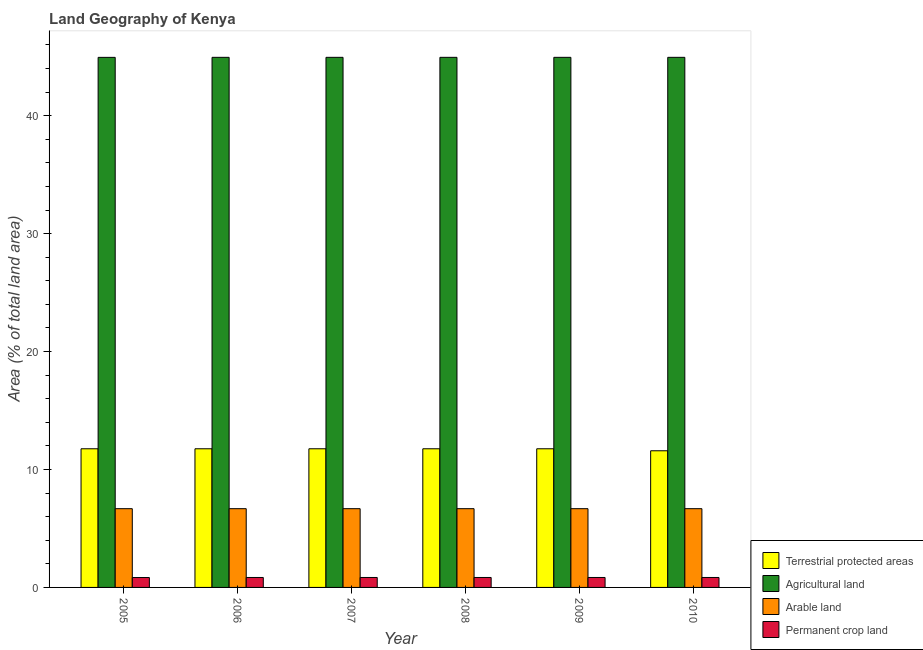How many different coloured bars are there?
Your answer should be compact. 4. How many groups of bars are there?
Offer a very short reply. 6. What is the label of the 1st group of bars from the left?
Your answer should be compact. 2005. What is the percentage of area under permanent crop land in 2008?
Make the answer very short. 0.84. Across all years, what is the maximum percentage of area under permanent crop land?
Your answer should be very brief. 0.84. Across all years, what is the minimum percentage of area under arable land?
Keep it short and to the point. 6.68. In which year was the percentage of area under agricultural land maximum?
Offer a very short reply. 2006. What is the total percentage of area under arable land in the graph?
Keep it short and to the point. 40.06. What is the difference between the percentage of area under agricultural land in 2008 and the percentage of area under permanent crop land in 2006?
Your answer should be compact. 0. What is the average percentage of area under permanent crop land per year?
Provide a succinct answer. 0.84. In how many years, is the percentage of area under permanent crop land greater than 36 %?
Ensure brevity in your answer.  0. What is the ratio of the percentage of area under arable land in 2006 to that in 2009?
Keep it short and to the point. 1. Is the difference between the percentage of area under permanent crop land in 2008 and 2010 greater than the difference between the percentage of land under terrestrial protection in 2008 and 2010?
Provide a succinct answer. No. What is the difference between the highest and the lowest percentage of land under terrestrial protection?
Your response must be concise. 0.17. In how many years, is the percentage of area under permanent crop land greater than the average percentage of area under permanent crop land taken over all years?
Your response must be concise. 5. Is the sum of the percentage of area under arable land in 2005 and 2008 greater than the maximum percentage of land under terrestrial protection across all years?
Give a very brief answer. Yes. Is it the case that in every year, the sum of the percentage of area under permanent crop land and percentage of area under arable land is greater than the sum of percentage of area under agricultural land and percentage of land under terrestrial protection?
Provide a short and direct response. No. What does the 4th bar from the left in 2010 represents?
Keep it short and to the point. Permanent crop land. What does the 4th bar from the right in 2008 represents?
Offer a terse response. Terrestrial protected areas. Are all the bars in the graph horizontal?
Offer a very short reply. No. How many years are there in the graph?
Ensure brevity in your answer.  6. Does the graph contain grids?
Make the answer very short. No. How many legend labels are there?
Your response must be concise. 4. How are the legend labels stacked?
Provide a succinct answer. Vertical. What is the title of the graph?
Provide a short and direct response. Land Geography of Kenya. What is the label or title of the X-axis?
Your answer should be compact. Year. What is the label or title of the Y-axis?
Ensure brevity in your answer.  Area (% of total land area). What is the Area (% of total land area) of Terrestrial protected areas in 2005?
Provide a short and direct response. 11.76. What is the Area (% of total land area) of Agricultural land in 2005?
Offer a terse response. 44.94. What is the Area (% of total land area) in Arable land in 2005?
Offer a very short reply. 6.68. What is the Area (% of total land area) of Permanent crop land in 2005?
Keep it short and to the point. 0.84. What is the Area (% of total land area) in Terrestrial protected areas in 2006?
Ensure brevity in your answer.  11.76. What is the Area (% of total land area) in Agricultural land in 2006?
Your answer should be very brief. 44.95. What is the Area (% of total land area) of Arable land in 2006?
Provide a succinct answer. 6.68. What is the Area (% of total land area) of Permanent crop land in 2006?
Make the answer very short. 0.84. What is the Area (% of total land area) in Terrestrial protected areas in 2007?
Your answer should be very brief. 11.76. What is the Area (% of total land area) in Agricultural land in 2007?
Offer a very short reply. 44.95. What is the Area (% of total land area) of Arable land in 2007?
Your answer should be very brief. 6.68. What is the Area (% of total land area) in Permanent crop land in 2007?
Offer a very short reply. 0.84. What is the Area (% of total land area) of Terrestrial protected areas in 2008?
Provide a succinct answer. 11.76. What is the Area (% of total land area) in Agricultural land in 2008?
Offer a very short reply. 44.95. What is the Area (% of total land area) of Arable land in 2008?
Make the answer very short. 6.68. What is the Area (% of total land area) in Permanent crop land in 2008?
Provide a short and direct response. 0.84. What is the Area (% of total land area) in Terrestrial protected areas in 2009?
Your answer should be very brief. 11.76. What is the Area (% of total land area) in Agricultural land in 2009?
Your answer should be very brief. 44.95. What is the Area (% of total land area) in Arable land in 2009?
Provide a succinct answer. 6.68. What is the Area (% of total land area) in Permanent crop land in 2009?
Offer a very short reply. 0.84. What is the Area (% of total land area) of Terrestrial protected areas in 2010?
Ensure brevity in your answer.  11.59. What is the Area (% of total land area) in Agricultural land in 2010?
Provide a succinct answer. 44.95. What is the Area (% of total land area) of Arable land in 2010?
Your response must be concise. 6.68. What is the Area (% of total land area) in Permanent crop land in 2010?
Keep it short and to the point. 0.84. Across all years, what is the maximum Area (% of total land area) of Terrestrial protected areas?
Keep it short and to the point. 11.76. Across all years, what is the maximum Area (% of total land area) in Agricultural land?
Give a very brief answer. 44.95. Across all years, what is the maximum Area (% of total land area) of Arable land?
Offer a very short reply. 6.68. Across all years, what is the maximum Area (% of total land area) of Permanent crop land?
Offer a terse response. 0.84. Across all years, what is the minimum Area (% of total land area) in Terrestrial protected areas?
Make the answer very short. 11.59. Across all years, what is the minimum Area (% of total land area) in Agricultural land?
Offer a terse response. 44.94. Across all years, what is the minimum Area (% of total land area) in Arable land?
Your answer should be very brief. 6.68. Across all years, what is the minimum Area (% of total land area) in Permanent crop land?
Ensure brevity in your answer.  0.84. What is the total Area (% of total land area) of Terrestrial protected areas in the graph?
Keep it short and to the point. 70.37. What is the total Area (% of total land area) of Agricultural land in the graph?
Keep it short and to the point. 269.67. What is the total Area (% of total land area) in Arable land in the graph?
Your answer should be compact. 40.06. What is the total Area (% of total land area) of Permanent crop land in the graph?
Keep it short and to the point. 5.06. What is the difference between the Area (% of total land area) of Terrestrial protected areas in 2005 and that in 2006?
Keep it short and to the point. 0. What is the difference between the Area (% of total land area) of Agricultural land in 2005 and that in 2006?
Your answer should be compact. -0. What is the difference between the Area (% of total land area) of Arable land in 2005 and that in 2006?
Ensure brevity in your answer.  0. What is the difference between the Area (% of total land area) in Permanent crop land in 2005 and that in 2006?
Keep it short and to the point. -0. What is the difference between the Area (% of total land area) of Agricultural land in 2005 and that in 2007?
Ensure brevity in your answer.  -0. What is the difference between the Area (% of total land area) of Permanent crop land in 2005 and that in 2007?
Provide a succinct answer. -0. What is the difference between the Area (% of total land area) in Terrestrial protected areas in 2005 and that in 2008?
Ensure brevity in your answer.  0. What is the difference between the Area (% of total land area) in Agricultural land in 2005 and that in 2008?
Your response must be concise. -0. What is the difference between the Area (% of total land area) of Permanent crop land in 2005 and that in 2008?
Your answer should be very brief. -0. What is the difference between the Area (% of total land area) in Agricultural land in 2005 and that in 2009?
Your answer should be very brief. -0. What is the difference between the Area (% of total land area) in Permanent crop land in 2005 and that in 2009?
Your answer should be very brief. -0. What is the difference between the Area (% of total land area) in Terrestrial protected areas in 2005 and that in 2010?
Make the answer very short. 0.17. What is the difference between the Area (% of total land area) in Agricultural land in 2005 and that in 2010?
Offer a very short reply. -0. What is the difference between the Area (% of total land area) in Permanent crop land in 2005 and that in 2010?
Keep it short and to the point. -0. What is the difference between the Area (% of total land area) in Terrestrial protected areas in 2006 and that in 2007?
Provide a succinct answer. 0. What is the difference between the Area (% of total land area) of Terrestrial protected areas in 2006 and that in 2008?
Provide a short and direct response. 0. What is the difference between the Area (% of total land area) of Arable land in 2006 and that in 2008?
Make the answer very short. 0. What is the difference between the Area (% of total land area) of Permanent crop land in 2006 and that in 2008?
Provide a short and direct response. 0. What is the difference between the Area (% of total land area) of Terrestrial protected areas in 2006 and that in 2009?
Make the answer very short. 0. What is the difference between the Area (% of total land area) of Agricultural land in 2006 and that in 2009?
Keep it short and to the point. 0. What is the difference between the Area (% of total land area) in Arable land in 2006 and that in 2009?
Offer a terse response. 0. What is the difference between the Area (% of total land area) in Terrestrial protected areas in 2006 and that in 2010?
Ensure brevity in your answer.  0.17. What is the difference between the Area (% of total land area) of Terrestrial protected areas in 2007 and that in 2008?
Your answer should be very brief. 0. What is the difference between the Area (% of total land area) in Arable land in 2007 and that in 2008?
Provide a succinct answer. 0. What is the difference between the Area (% of total land area) in Arable land in 2007 and that in 2009?
Provide a succinct answer. 0. What is the difference between the Area (% of total land area) in Terrestrial protected areas in 2007 and that in 2010?
Offer a very short reply. 0.17. What is the difference between the Area (% of total land area) of Permanent crop land in 2007 and that in 2010?
Ensure brevity in your answer.  0. What is the difference between the Area (% of total land area) of Arable land in 2008 and that in 2009?
Offer a terse response. 0. What is the difference between the Area (% of total land area) of Terrestrial protected areas in 2008 and that in 2010?
Offer a terse response. 0.17. What is the difference between the Area (% of total land area) of Agricultural land in 2008 and that in 2010?
Your answer should be very brief. 0. What is the difference between the Area (% of total land area) of Arable land in 2008 and that in 2010?
Offer a very short reply. 0. What is the difference between the Area (% of total land area) in Permanent crop land in 2008 and that in 2010?
Your response must be concise. 0. What is the difference between the Area (% of total land area) of Terrestrial protected areas in 2009 and that in 2010?
Your answer should be very brief. 0.17. What is the difference between the Area (% of total land area) of Agricultural land in 2009 and that in 2010?
Your answer should be very brief. 0. What is the difference between the Area (% of total land area) of Permanent crop land in 2009 and that in 2010?
Keep it short and to the point. 0. What is the difference between the Area (% of total land area) of Terrestrial protected areas in 2005 and the Area (% of total land area) of Agricultural land in 2006?
Give a very brief answer. -33.19. What is the difference between the Area (% of total land area) of Terrestrial protected areas in 2005 and the Area (% of total land area) of Arable land in 2006?
Provide a succinct answer. 5.08. What is the difference between the Area (% of total land area) in Terrestrial protected areas in 2005 and the Area (% of total land area) in Permanent crop land in 2006?
Offer a very short reply. 10.91. What is the difference between the Area (% of total land area) in Agricultural land in 2005 and the Area (% of total land area) in Arable land in 2006?
Give a very brief answer. 38.26. What is the difference between the Area (% of total land area) of Agricultural land in 2005 and the Area (% of total land area) of Permanent crop land in 2006?
Your response must be concise. 44.1. What is the difference between the Area (% of total land area) in Arable land in 2005 and the Area (% of total land area) in Permanent crop land in 2006?
Make the answer very short. 5.83. What is the difference between the Area (% of total land area) in Terrestrial protected areas in 2005 and the Area (% of total land area) in Agricultural land in 2007?
Your answer should be very brief. -33.19. What is the difference between the Area (% of total land area) in Terrestrial protected areas in 2005 and the Area (% of total land area) in Arable land in 2007?
Offer a terse response. 5.08. What is the difference between the Area (% of total land area) in Terrestrial protected areas in 2005 and the Area (% of total land area) in Permanent crop land in 2007?
Give a very brief answer. 10.91. What is the difference between the Area (% of total land area) of Agricultural land in 2005 and the Area (% of total land area) of Arable land in 2007?
Your response must be concise. 38.26. What is the difference between the Area (% of total land area) of Agricultural land in 2005 and the Area (% of total land area) of Permanent crop land in 2007?
Ensure brevity in your answer.  44.1. What is the difference between the Area (% of total land area) of Arable land in 2005 and the Area (% of total land area) of Permanent crop land in 2007?
Offer a terse response. 5.83. What is the difference between the Area (% of total land area) of Terrestrial protected areas in 2005 and the Area (% of total land area) of Agricultural land in 2008?
Your response must be concise. -33.19. What is the difference between the Area (% of total land area) of Terrestrial protected areas in 2005 and the Area (% of total land area) of Arable land in 2008?
Offer a terse response. 5.08. What is the difference between the Area (% of total land area) of Terrestrial protected areas in 2005 and the Area (% of total land area) of Permanent crop land in 2008?
Provide a succinct answer. 10.91. What is the difference between the Area (% of total land area) of Agricultural land in 2005 and the Area (% of total land area) of Arable land in 2008?
Keep it short and to the point. 38.26. What is the difference between the Area (% of total land area) in Agricultural land in 2005 and the Area (% of total land area) in Permanent crop land in 2008?
Keep it short and to the point. 44.1. What is the difference between the Area (% of total land area) in Arable land in 2005 and the Area (% of total land area) in Permanent crop land in 2008?
Your answer should be very brief. 5.83. What is the difference between the Area (% of total land area) of Terrestrial protected areas in 2005 and the Area (% of total land area) of Agricultural land in 2009?
Provide a succinct answer. -33.19. What is the difference between the Area (% of total land area) in Terrestrial protected areas in 2005 and the Area (% of total land area) in Arable land in 2009?
Provide a short and direct response. 5.08. What is the difference between the Area (% of total land area) of Terrestrial protected areas in 2005 and the Area (% of total land area) of Permanent crop land in 2009?
Provide a short and direct response. 10.91. What is the difference between the Area (% of total land area) of Agricultural land in 2005 and the Area (% of total land area) of Arable land in 2009?
Make the answer very short. 38.26. What is the difference between the Area (% of total land area) of Agricultural land in 2005 and the Area (% of total land area) of Permanent crop land in 2009?
Offer a very short reply. 44.1. What is the difference between the Area (% of total land area) in Arable land in 2005 and the Area (% of total land area) in Permanent crop land in 2009?
Your answer should be compact. 5.83. What is the difference between the Area (% of total land area) of Terrestrial protected areas in 2005 and the Area (% of total land area) of Agricultural land in 2010?
Your answer should be very brief. -33.19. What is the difference between the Area (% of total land area) of Terrestrial protected areas in 2005 and the Area (% of total land area) of Arable land in 2010?
Keep it short and to the point. 5.08. What is the difference between the Area (% of total land area) of Terrestrial protected areas in 2005 and the Area (% of total land area) of Permanent crop land in 2010?
Your answer should be very brief. 10.91. What is the difference between the Area (% of total land area) of Agricultural land in 2005 and the Area (% of total land area) of Arable land in 2010?
Keep it short and to the point. 38.26. What is the difference between the Area (% of total land area) in Agricultural land in 2005 and the Area (% of total land area) in Permanent crop land in 2010?
Your answer should be very brief. 44.1. What is the difference between the Area (% of total land area) in Arable land in 2005 and the Area (% of total land area) in Permanent crop land in 2010?
Offer a terse response. 5.83. What is the difference between the Area (% of total land area) of Terrestrial protected areas in 2006 and the Area (% of total land area) of Agricultural land in 2007?
Ensure brevity in your answer.  -33.19. What is the difference between the Area (% of total land area) in Terrestrial protected areas in 2006 and the Area (% of total land area) in Arable land in 2007?
Provide a succinct answer. 5.08. What is the difference between the Area (% of total land area) in Terrestrial protected areas in 2006 and the Area (% of total land area) in Permanent crop land in 2007?
Ensure brevity in your answer.  10.91. What is the difference between the Area (% of total land area) of Agricultural land in 2006 and the Area (% of total land area) of Arable land in 2007?
Your answer should be compact. 38.27. What is the difference between the Area (% of total land area) in Agricultural land in 2006 and the Area (% of total land area) in Permanent crop land in 2007?
Offer a terse response. 44.1. What is the difference between the Area (% of total land area) in Arable land in 2006 and the Area (% of total land area) in Permanent crop land in 2007?
Offer a terse response. 5.83. What is the difference between the Area (% of total land area) of Terrestrial protected areas in 2006 and the Area (% of total land area) of Agricultural land in 2008?
Your answer should be compact. -33.19. What is the difference between the Area (% of total land area) in Terrestrial protected areas in 2006 and the Area (% of total land area) in Arable land in 2008?
Offer a terse response. 5.08. What is the difference between the Area (% of total land area) in Terrestrial protected areas in 2006 and the Area (% of total land area) in Permanent crop land in 2008?
Your response must be concise. 10.91. What is the difference between the Area (% of total land area) in Agricultural land in 2006 and the Area (% of total land area) in Arable land in 2008?
Offer a very short reply. 38.27. What is the difference between the Area (% of total land area) of Agricultural land in 2006 and the Area (% of total land area) of Permanent crop land in 2008?
Offer a terse response. 44.1. What is the difference between the Area (% of total land area) of Arable land in 2006 and the Area (% of total land area) of Permanent crop land in 2008?
Offer a terse response. 5.83. What is the difference between the Area (% of total land area) in Terrestrial protected areas in 2006 and the Area (% of total land area) in Agricultural land in 2009?
Offer a very short reply. -33.19. What is the difference between the Area (% of total land area) of Terrestrial protected areas in 2006 and the Area (% of total land area) of Arable land in 2009?
Your answer should be very brief. 5.08. What is the difference between the Area (% of total land area) in Terrestrial protected areas in 2006 and the Area (% of total land area) in Permanent crop land in 2009?
Give a very brief answer. 10.91. What is the difference between the Area (% of total land area) of Agricultural land in 2006 and the Area (% of total land area) of Arable land in 2009?
Provide a short and direct response. 38.27. What is the difference between the Area (% of total land area) in Agricultural land in 2006 and the Area (% of total land area) in Permanent crop land in 2009?
Give a very brief answer. 44.1. What is the difference between the Area (% of total land area) in Arable land in 2006 and the Area (% of total land area) in Permanent crop land in 2009?
Your answer should be very brief. 5.83. What is the difference between the Area (% of total land area) of Terrestrial protected areas in 2006 and the Area (% of total land area) of Agricultural land in 2010?
Provide a short and direct response. -33.19. What is the difference between the Area (% of total land area) in Terrestrial protected areas in 2006 and the Area (% of total land area) in Arable land in 2010?
Your response must be concise. 5.08. What is the difference between the Area (% of total land area) in Terrestrial protected areas in 2006 and the Area (% of total land area) in Permanent crop land in 2010?
Keep it short and to the point. 10.91. What is the difference between the Area (% of total land area) of Agricultural land in 2006 and the Area (% of total land area) of Arable land in 2010?
Offer a very short reply. 38.27. What is the difference between the Area (% of total land area) of Agricultural land in 2006 and the Area (% of total land area) of Permanent crop land in 2010?
Ensure brevity in your answer.  44.1. What is the difference between the Area (% of total land area) in Arable land in 2006 and the Area (% of total land area) in Permanent crop land in 2010?
Offer a terse response. 5.83. What is the difference between the Area (% of total land area) of Terrestrial protected areas in 2007 and the Area (% of total land area) of Agricultural land in 2008?
Your response must be concise. -33.19. What is the difference between the Area (% of total land area) in Terrestrial protected areas in 2007 and the Area (% of total land area) in Arable land in 2008?
Make the answer very short. 5.08. What is the difference between the Area (% of total land area) of Terrestrial protected areas in 2007 and the Area (% of total land area) of Permanent crop land in 2008?
Make the answer very short. 10.91. What is the difference between the Area (% of total land area) of Agricultural land in 2007 and the Area (% of total land area) of Arable land in 2008?
Give a very brief answer. 38.27. What is the difference between the Area (% of total land area) of Agricultural land in 2007 and the Area (% of total land area) of Permanent crop land in 2008?
Your answer should be compact. 44.1. What is the difference between the Area (% of total land area) of Arable land in 2007 and the Area (% of total land area) of Permanent crop land in 2008?
Give a very brief answer. 5.83. What is the difference between the Area (% of total land area) of Terrestrial protected areas in 2007 and the Area (% of total land area) of Agricultural land in 2009?
Make the answer very short. -33.19. What is the difference between the Area (% of total land area) in Terrestrial protected areas in 2007 and the Area (% of total land area) in Arable land in 2009?
Provide a succinct answer. 5.08. What is the difference between the Area (% of total land area) in Terrestrial protected areas in 2007 and the Area (% of total land area) in Permanent crop land in 2009?
Offer a terse response. 10.91. What is the difference between the Area (% of total land area) of Agricultural land in 2007 and the Area (% of total land area) of Arable land in 2009?
Make the answer very short. 38.27. What is the difference between the Area (% of total land area) in Agricultural land in 2007 and the Area (% of total land area) in Permanent crop land in 2009?
Keep it short and to the point. 44.1. What is the difference between the Area (% of total land area) in Arable land in 2007 and the Area (% of total land area) in Permanent crop land in 2009?
Provide a succinct answer. 5.83. What is the difference between the Area (% of total land area) of Terrestrial protected areas in 2007 and the Area (% of total land area) of Agricultural land in 2010?
Your answer should be compact. -33.19. What is the difference between the Area (% of total land area) in Terrestrial protected areas in 2007 and the Area (% of total land area) in Arable land in 2010?
Your answer should be compact. 5.08. What is the difference between the Area (% of total land area) in Terrestrial protected areas in 2007 and the Area (% of total land area) in Permanent crop land in 2010?
Your answer should be compact. 10.91. What is the difference between the Area (% of total land area) of Agricultural land in 2007 and the Area (% of total land area) of Arable land in 2010?
Make the answer very short. 38.27. What is the difference between the Area (% of total land area) in Agricultural land in 2007 and the Area (% of total land area) in Permanent crop land in 2010?
Your answer should be compact. 44.1. What is the difference between the Area (% of total land area) in Arable land in 2007 and the Area (% of total land area) in Permanent crop land in 2010?
Your answer should be compact. 5.83. What is the difference between the Area (% of total land area) of Terrestrial protected areas in 2008 and the Area (% of total land area) of Agricultural land in 2009?
Ensure brevity in your answer.  -33.19. What is the difference between the Area (% of total land area) of Terrestrial protected areas in 2008 and the Area (% of total land area) of Arable land in 2009?
Make the answer very short. 5.08. What is the difference between the Area (% of total land area) of Terrestrial protected areas in 2008 and the Area (% of total land area) of Permanent crop land in 2009?
Offer a terse response. 10.91. What is the difference between the Area (% of total land area) of Agricultural land in 2008 and the Area (% of total land area) of Arable land in 2009?
Your answer should be compact. 38.27. What is the difference between the Area (% of total land area) in Agricultural land in 2008 and the Area (% of total land area) in Permanent crop land in 2009?
Give a very brief answer. 44.1. What is the difference between the Area (% of total land area) of Arable land in 2008 and the Area (% of total land area) of Permanent crop land in 2009?
Provide a succinct answer. 5.83. What is the difference between the Area (% of total land area) of Terrestrial protected areas in 2008 and the Area (% of total land area) of Agricultural land in 2010?
Provide a short and direct response. -33.19. What is the difference between the Area (% of total land area) of Terrestrial protected areas in 2008 and the Area (% of total land area) of Arable land in 2010?
Keep it short and to the point. 5.08. What is the difference between the Area (% of total land area) in Terrestrial protected areas in 2008 and the Area (% of total land area) in Permanent crop land in 2010?
Your answer should be compact. 10.91. What is the difference between the Area (% of total land area) of Agricultural land in 2008 and the Area (% of total land area) of Arable land in 2010?
Your answer should be very brief. 38.27. What is the difference between the Area (% of total land area) in Agricultural land in 2008 and the Area (% of total land area) in Permanent crop land in 2010?
Provide a short and direct response. 44.1. What is the difference between the Area (% of total land area) in Arable land in 2008 and the Area (% of total land area) in Permanent crop land in 2010?
Your answer should be compact. 5.83. What is the difference between the Area (% of total land area) of Terrestrial protected areas in 2009 and the Area (% of total land area) of Agricultural land in 2010?
Provide a succinct answer. -33.19. What is the difference between the Area (% of total land area) of Terrestrial protected areas in 2009 and the Area (% of total land area) of Arable land in 2010?
Provide a succinct answer. 5.08. What is the difference between the Area (% of total land area) in Terrestrial protected areas in 2009 and the Area (% of total land area) in Permanent crop land in 2010?
Your answer should be compact. 10.91. What is the difference between the Area (% of total land area) in Agricultural land in 2009 and the Area (% of total land area) in Arable land in 2010?
Ensure brevity in your answer.  38.27. What is the difference between the Area (% of total land area) of Agricultural land in 2009 and the Area (% of total land area) of Permanent crop land in 2010?
Provide a short and direct response. 44.1. What is the difference between the Area (% of total land area) in Arable land in 2009 and the Area (% of total land area) in Permanent crop land in 2010?
Offer a very short reply. 5.83. What is the average Area (% of total land area) in Terrestrial protected areas per year?
Your response must be concise. 11.73. What is the average Area (% of total land area) in Agricultural land per year?
Provide a short and direct response. 44.94. What is the average Area (% of total land area) of Arable land per year?
Provide a short and direct response. 6.68. What is the average Area (% of total land area) in Permanent crop land per year?
Your answer should be compact. 0.84. In the year 2005, what is the difference between the Area (% of total land area) of Terrestrial protected areas and Area (% of total land area) of Agricultural land?
Offer a very short reply. -33.19. In the year 2005, what is the difference between the Area (% of total land area) of Terrestrial protected areas and Area (% of total land area) of Arable land?
Make the answer very short. 5.08. In the year 2005, what is the difference between the Area (% of total land area) of Terrestrial protected areas and Area (% of total land area) of Permanent crop land?
Your response must be concise. 10.92. In the year 2005, what is the difference between the Area (% of total land area) in Agricultural land and Area (% of total land area) in Arable land?
Provide a short and direct response. 38.26. In the year 2005, what is the difference between the Area (% of total land area) in Agricultural land and Area (% of total land area) in Permanent crop land?
Offer a terse response. 44.1. In the year 2005, what is the difference between the Area (% of total land area) of Arable land and Area (% of total land area) of Permanent crop land?
Your answer should be compact. 5.84. In the year 2006, what is the difference between the Area (% of total land area) of Terrestrial protected areas and Area (% of total land area) of Agricultural land?
Keep it short and to the point. -33.19. In the year 2006, what is the difference between the Area (% of total land area) of Terrestrial protected areas and Area (% of total land area) of Arable land?
Keep it short and to the point. 5.08. In the year 2006, what is the difference between the Area (% of total land area) of Terrestrial protected areas and Area (% of total land area) of Permanent crop land?
Provide a short and direct response. 10.91. In the year 2006, what is the difference between the Area (% of total land area) of Agricultural land and Area (% of total land area) of Arable land?
Ensure brevity in your answer.  38.27. In the year 2006, what is the difference between the Area (% of total land area) in Agricultural land and Area (% of total land area) in Permanent crop land?
Keep it short and to the point. 44.1. In the year 2006, what is the difference between the Area (% of total land area) of Arable land and Area (% of total land area) of Permanent crop land?
Offer a very short reply. 5.83. In the year 2007, what is the difference between the Area (% of total land area) in Terrestrial protected areas and Area (% of total land area) in Agricultural land?
Offer a very short reply. -33.19. In the year 2007, what is the difference between the Area (% of total land area) in Terrestrial protected areas and Area (% of total land area) in Arable land?
Keep it short and to the point. 5.08. In the year 2007, what is the difference between the Area (% of total land area) of Terrestrial protected areas and Area (% of total land area) of Permanent crop land?
Offer a terse response. 10.91. In the year 2007, what is the difference between the Area (% of total land area) in Agricultural land and Area (% of total land area) in Arable land?
Provide a short and direct response. 38.27. In the year 2007, what is the difference between the Area (% of total land area) in Agricultural land and Area (% of total land area) in Permanent crop land?
Give a very brief answer. 44.1. In the year 2007, what is the difference between the Area (% of total land area) in Arable land and Area (% of total land area) in Permanent crop land?
Offer a terse response. 5.83. In the year 2008, what is the difference between the Area (% of total land area) in Terrestrial protected areas and Area (% of total land area) in Agricultural land?
Ensure brevity in your answer.  -33.19. In the year 2008, what is the difference between the Area (% of total land area) in Terrestrial protected areas and Area (% of total land area) in Arable land?
Your answer should be compact. 5.08. In the year 2008, what is the difference between the Area (% of total land area) in Terrestrial protected areas and Area (% of total land area) in Permanent crop land?
Make the answer very short. 10.91. In the year 2008, what is the difference between the Area (% of total land area) in Agricultural land and Area (% of total land area) in Arable land?
Give a very brief answer. 38.27. In the year 2008, what is the difference between the Area (% of total land area) of Agricultural land and Area (% of total land area) of Permanent crop land?
Keep it short and to the point. 44.1. In the year 2008, what is the difference between the Area (% of total land area) in Arable land and Area (% of total land area) in Permanent crop land?
Provide a succinct answer. 5.83. In the year 2009, what is the difference between the Area (% of total land area) of Terrestrial protected areas and Area (% of total land area) of Agricultural land?
Your answer should be compact. -33.19. In the year 2009, what is the difference between the Area (% of total land area) of Terrestrial protected areas and Area (% of total land area) of Arable land?
Your response must be concise. 5.08. In the year 2009, what is the difference between the Area (% of total land area) in Terrestrial protected areas and Area (% of total land area) in Permanent crop land?
Your answer should be very brief. 10.91. In the year 2009, what is the difference between the Area (% of total land area) of Agricultural land and Area (% of total land area) of Arable land?
Make the answer very short. 38.27. In the year 2009, what is the difference between the Area (% of total land area) of Agricultural land and Area (% of total land area) of Permanent crop land?
Offer a terse response. 44.1. In the year 2009, what is the difference between the Area (% of total land area) in Arable land and Area (% of total land area) in Permanent crop land?
Your answer should be compact. 5.83. In the year 2010, what is the difference between the Area (% of total land area) in Terrestrial protected areas and Area (% of total land area) in Agricultural land?
Offer a very short reply. -33.36. In the year 2010, what is the difference between the Area (% of total land area) in Terrestrial protected areas and Area (% of total land area) in Arable land?
Give a very brief answer. 4.91. In the year 2010, what is the difference between the Area (% of total land area) in Terrestrial protected areas and Area (% of total land area) in Permanent crop land?
Give a very brief answer. 10.74. In the year 2010, what is the difference between the Area (% of total land area) in Agricultural land and Area (% of total land area) in Arable land?
Make the answer very short. 38.27. In the year 2010, what is the difference between the Area (% of total land area) of Agricultural land and Area (% of total land area) of Permanent crop land?
Offer a terse response. 44.1. In the year 2010, what is the difference between the Area (% of total land area) of Arable land and Area (% of total land area) of Permanent crop land?
Offer a very short reply. 5.83. What is the ratio of the Area (% of total land area) of Agricultural land in 2005 to that in 2007?
Give a very brief answer. 1. What is the ratio of the Area (% of total land area) of Arable land in 2005 to that in 2007?
Your response must be concise. 1. What is the ratio of the Area (% of total land area) in Terrestrial protected areas in 2005 to that in 2008?
Offer a very short reply. 1. What is the ratio of the Area (% of total land area) in Arable land in 2005 to that in 2008?
Give a very brief answer. 1. What is the ratio of the Area (% of total land area) of Terrestrial protected areas in 2005 to that in 2009?
Your response must be concise. 1. What is the ratio of the Area (% of total land area) of Arable land in 2005 to that in 2009?
Ensure brevity in your answer.  1. What is the ratio of the Area (% of total land area) of Terrestrial protected areas in 2005 to that in 2010?
Keep it short and to the point. 1.01. What is the ratio of the Area (% of total land area) in Arable land in 2005 to that in 2010?
Provide a short and direct response. 1. What is the ratio of the Area (% of total land area) of Permanent crop land in 2005 to that in 2010?
Offer a very short reply. 1. What is the ratio of the Area (% of total land area) of Arable land in 2006 to that in 2007?
Ensure brevity in your answer.  1. What is the ratio of the Area (% of total land area) in Agricultural land in 2006 to that in 2008?
Provide a short and direct response. 1. What is the ratio of the Area (% of total land area) of Arable land in 2006 to that in 2008?
Make the answer very short. 1. What is the ratio of the Area (% of total land area) in Terrestrial protected areas in 2006 to that in 2009?
Provide a short and direct response. 1. What is the ratio of the Area (% of total land area) of Permanent crop land in 2006 to that in 2009?
Provide a succinct answer. 1. What is the ratio of the Area (% of total land area) of Terrestrial protected areas in 2006 to that in 2010?
Make the answer very short. 1.01. What is the ratio of the Area (% of total land area) of Arable land in 2006 to that in 2010?
Ensure brevity in your answer.  1. What is the ratio of the Area (% of total land area) in Terrestrial protected areas in 2007 to that in 2008?
Offer a terse response. 1. What is the ratio of the Area (% of total land area) of Agricultural land in 2007 to that in 2008?
Your answer should be very brief. 1. What is the ratio of the Area (% of total land area) in Arable land in 2007 to that in 2008?
Your answer should be compact. 1. What is the ratio of the Area (% of total land area) in Agricultural land in 2007 to that in 2009?
Make the answer very short. 1. What is the ratio of the Area (% of total land area) of Arable land in 2007 to that in 2009?
Offer a very short reply. 1. What is the ratio of the Area (% of total land area) in Permanent crop land in 2007 to that in 2009?
Ensure brevity in your answer.  1. What is the ratio of the Area (% of total land area) in Terrestrial protected areas in 2007 to that in 2010?
Offer a terse response. 1.01. What is the ratio of the Area (% of total land area) of Arable land in 2007 to that in 2010?
Keep it short and to the point. 1. What is the ratio of the Area (% of total land area) of Permanent crop land in 2007 to that in 2010?
Your answer should be very brief. 1. What is the ratio of the Area (% of total land area) of Terrestrial protected areas in 2008 to that in 2009?
Provide a short and direct response. 1. What is the ratio of the Area (% of total land area) in Agricultural land in 2008 to that in 2009?
Provide a short and direct response. 1. What is the ratio of the Area (% of total land area) of Arable land in 2008 to that in 2009?
Ensure brevity in your answer.  1. What is the ratio of the Area (% of total land area) of Terrestrial protected areas in 2008 to that in 2010?
Offer a terse response. 1.01. What is the ratio of the Area (% of total land area) of Terrestrial protected areas in 2009 to that in 2010?
Give a very brief answer. 1.01. What is the ratio of the Area (% of total land area) of Agricultural land in 2009 to that in 2010?
Make the answer very short. 1. What is the ratio of the Area (% of total land area) of Arable land in 2009 to that in 2010?
Offer a very short reply. 1. What is the ratio of the Area (% of total land area) in Permanent crop land in 2009 to that in 2010?
Keep it short and to the point. 1. What is the difference between the highest and the second highest Area (% of total land area) of Agricultural land?
Your response must be concise. 0. What is the difference between the highest and the second highest Area (% of total land area) in Arable land?
Your answer should be very brief. 0. What is the difference between the highest and the lowest Area (% of total land area) of Terrestrial protected areas?
Your response must be concise. 0.17. What is the difference between the highest and the lowest Area (% of total land area) of Agricultural land?
Your response must be concise. 0. What is the difference between the highest and the lowest Area (% of total land area) of Permanent crop land?
Offer a terse response. 0. 